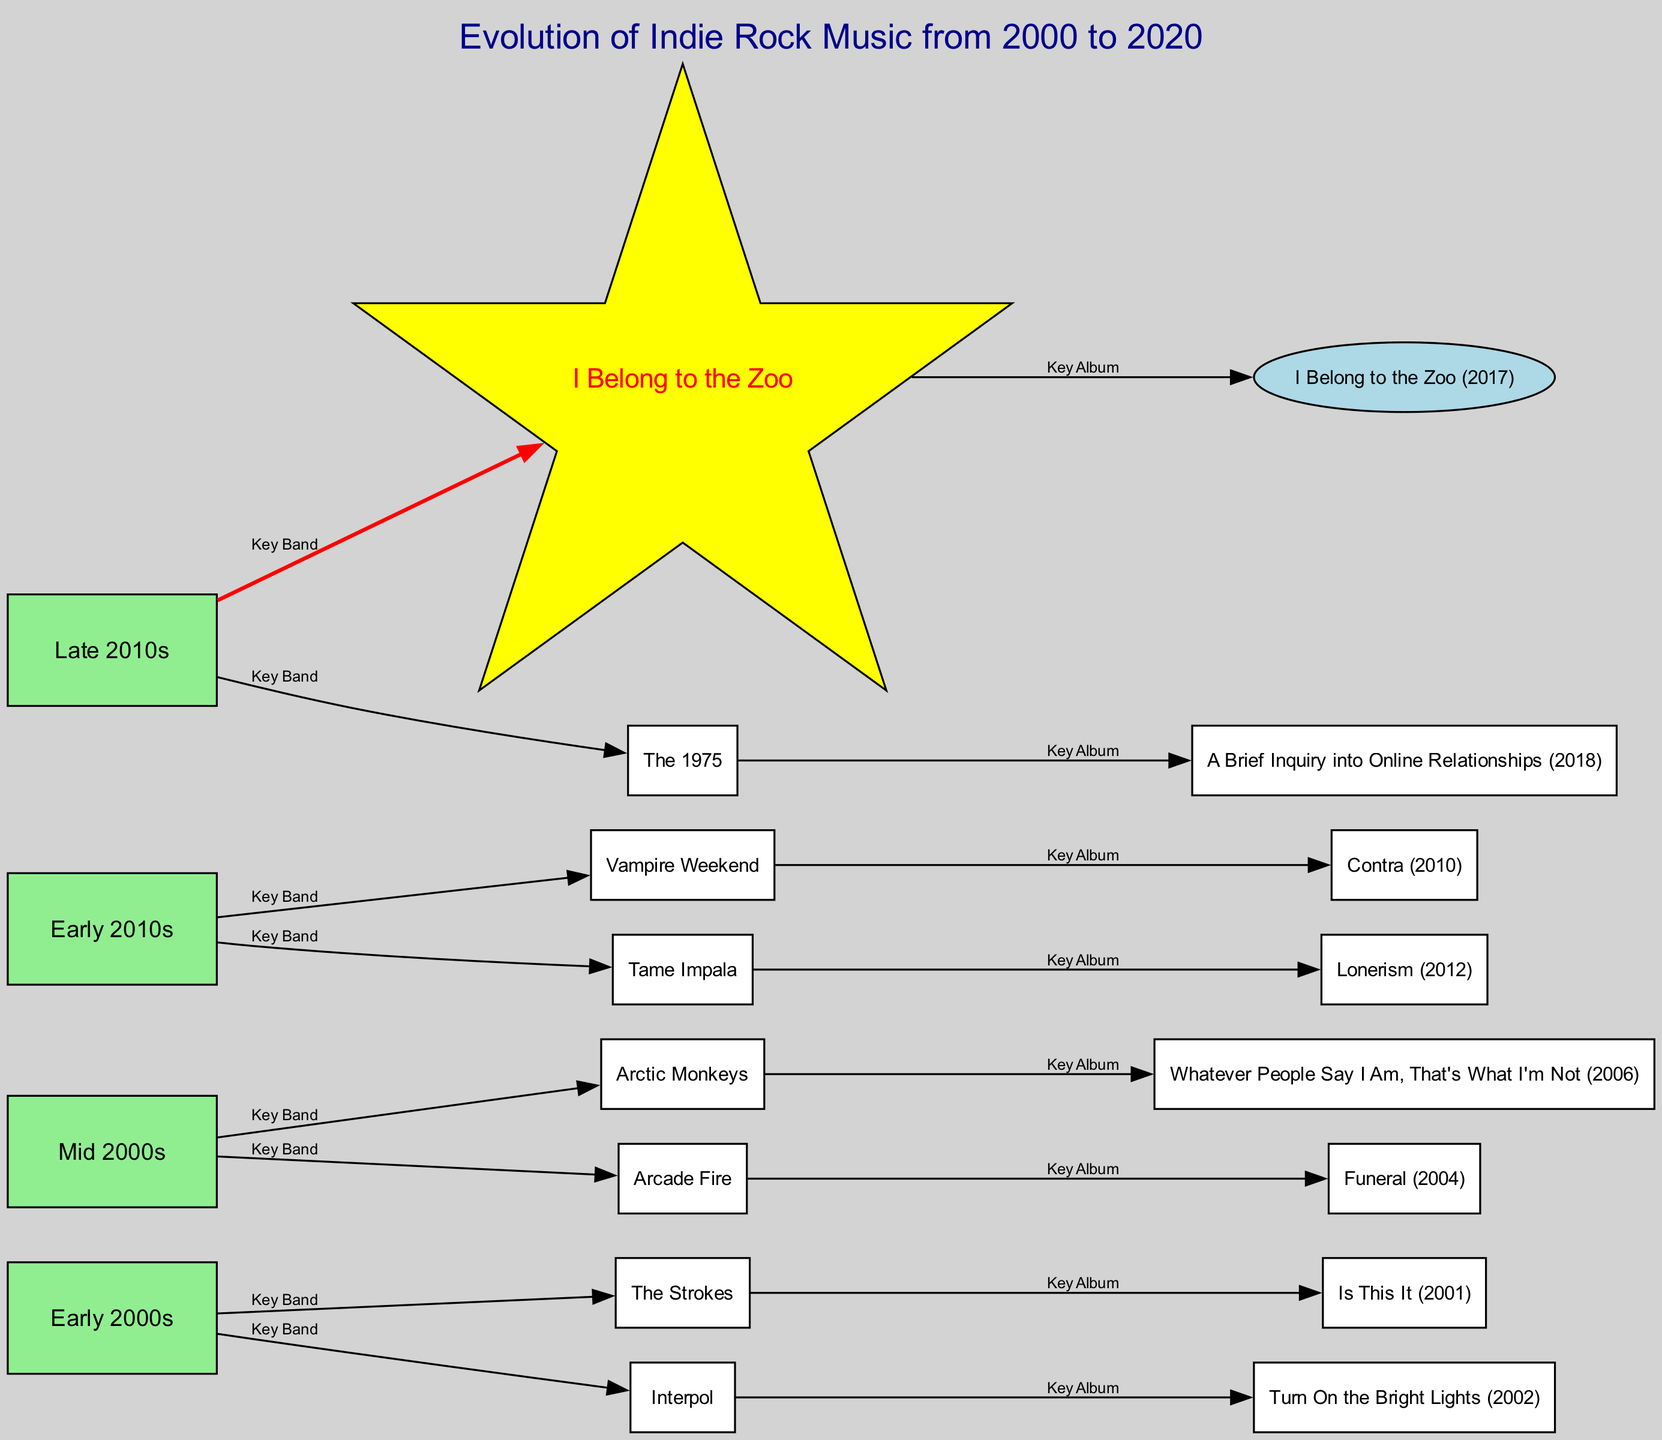What is the key album associated with The Strokes? The diagram shows a directed edge from The Strokes to the album "Is This It (2001)", indicating it is a key album associated with the band.
Answer: Is This It (2001) How many key bands are depicted in the Early 2000s section? In the Early 2000s section, there are two edges leading to key bands: The Strokes and Interpol, indicating a total of two key bands in this timeframe.
Answer: 2 Which band released the album "Funeral"? The directed edge indicates that "Funeral" is linked to Arcade Fire, which shows that Arcade Fire is the band that released this album.
Answer: Arcade Fire What is the unique shape used for the I Belong to the Zoo node? The diagram highlights I Belong to the Zoo using a star shape, which is distinct from other nodes that are common rectangles or ellipses.
Answer: Star Which decade saw the release of Vampire Weekend's "Contra"? The diagram places Vampire Weekend and "Contra" within the "Early 2010s" section, indicating that the decade for this release is the 2010s.
Answer: 2010s What key album is associated with The 1975? The directed edge connects The 1975 to the album "A Brief Inquiry into Online Relationships", clearly stating it as their key album.
Answer: A Brief Inquiry into Online Relationships Which two key bands were active in the Mid 2000s? The diagram shows edges connecting the Mid 2000s to two key bands: Arctic Monkeys and Arcade Fire, revealing both bands were active during this time.
Answer: Arctic Monkeys, Arcade Fire What year was the album "Lonerism" released? The edge from Tame Impala to "Lonerism" indicates it was released in 2012, as per the label associated with this album in the diagram.
Answer: 2012 